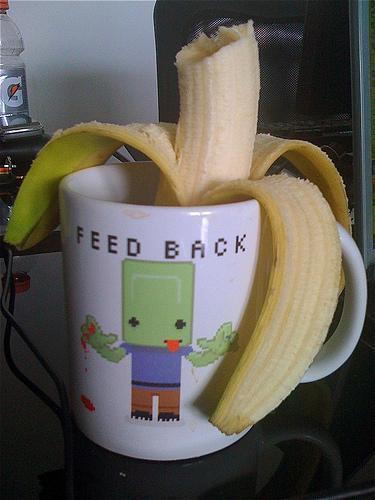How many words are visible?
Give a very brief answer. 2. 